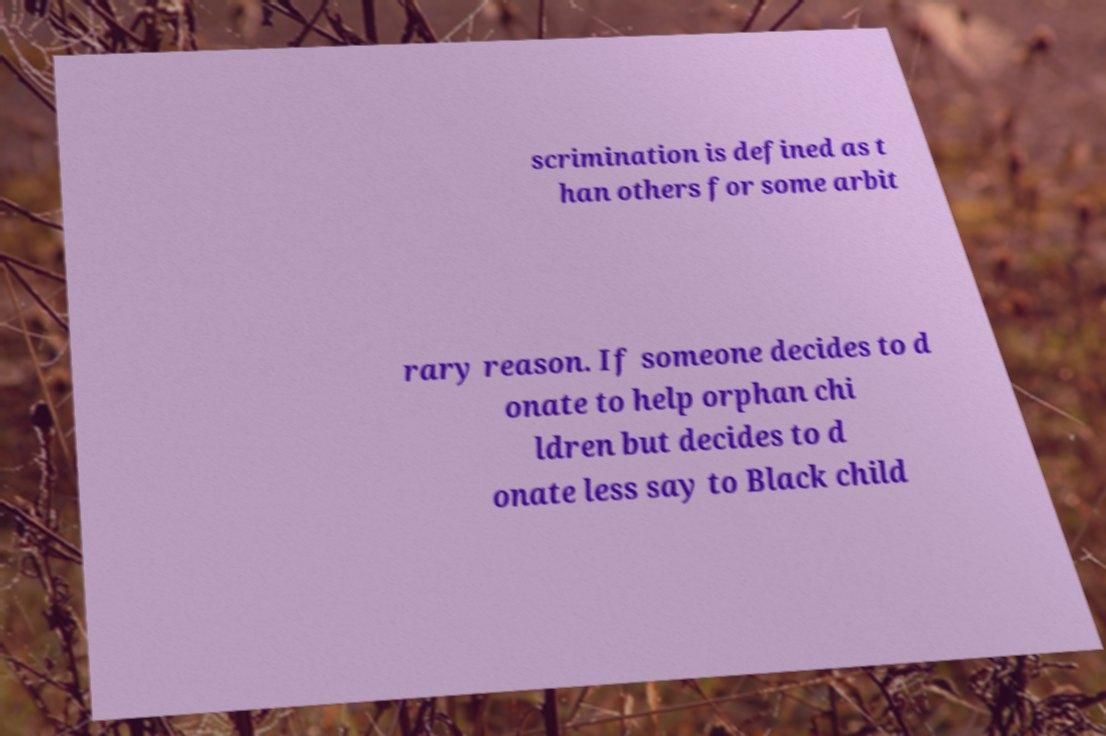There's text embedded in this image that I need extracted. Can you transcribe it verbatim? scrimination is defined as t han others for some arbit rary reason. If someone decides to d onate to help orphan chi ldren but decides to d onate less say to Black child 